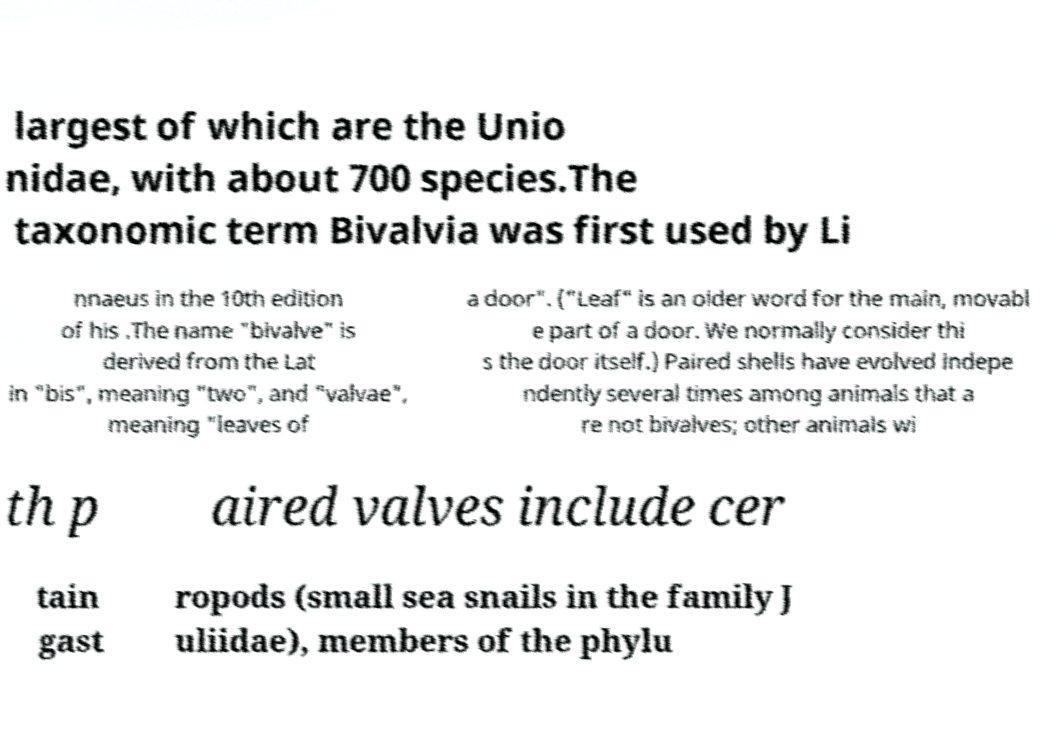Could you assist in decoding the text presented in this image and type it out clearly? largest of which are the Unio nidae, with about 700 species.The taxonomic term Bivalvia was first used by Li nnaeus in the 10th edition of his .The name "bivalve" is derived from the Lat in "bis", meaning "two", and "valvae", meaning "leaves of a door". ("Leaf" is an older word for the main, movabl e part of a door. We normally consider thi s the door itself.) Paired shells have evolved indepe ndently several times among animals that a re not bivalves; other animals wi th p aired valves include cer tain gast ropods (small sea snails in the family J uliidae), members of the phylu 